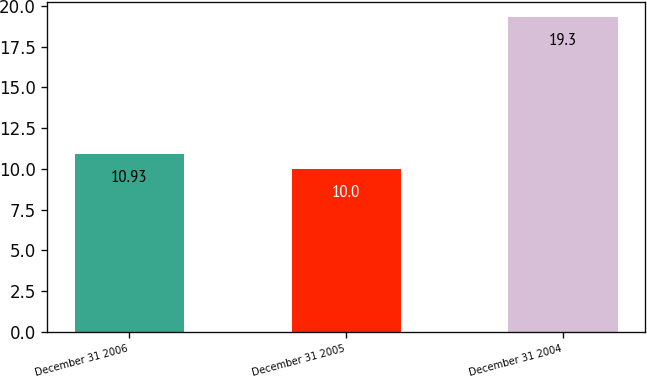Convert chart to OTSL. <chart><loc_0><loc_0><loc_500><loc_500><bar_chart><fcel>December 31 2006<fcel>December 31 2005<fcel>December 31 2004<nl><fcel>10.93<fcel>10<fcel>19.3<nl></chart> 